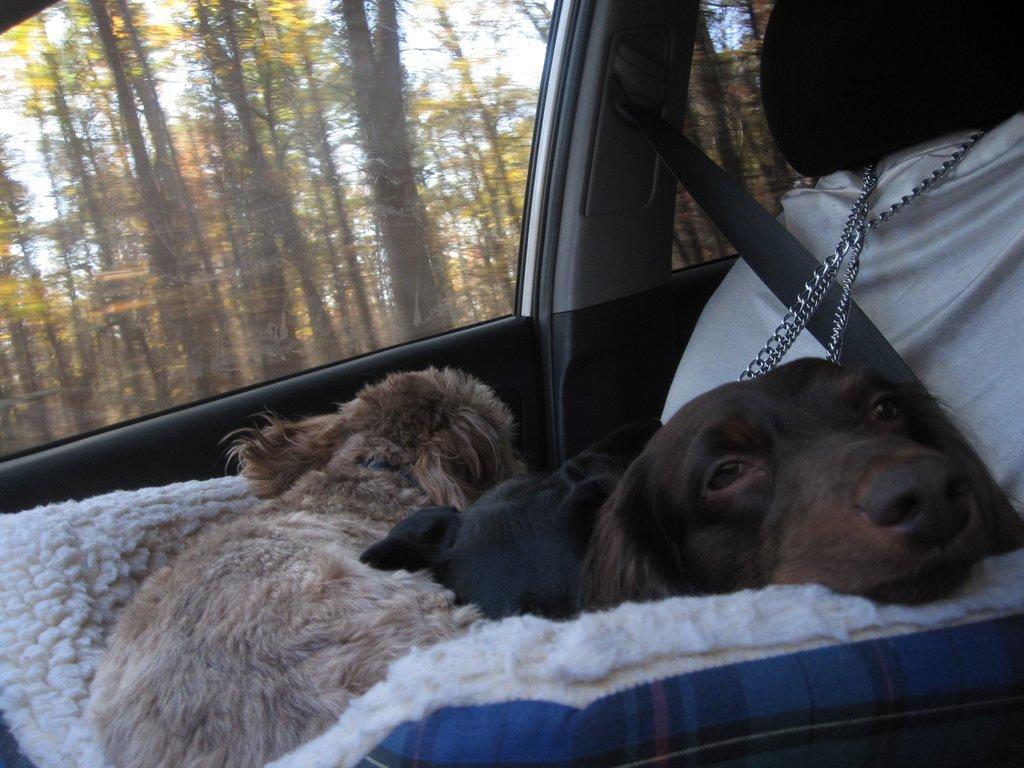Please provide a concise description of this image. This is inside of a vehicle,we can see dogs on cloth and we can see seat,glass window and seat belt,through this window we can see trees. 